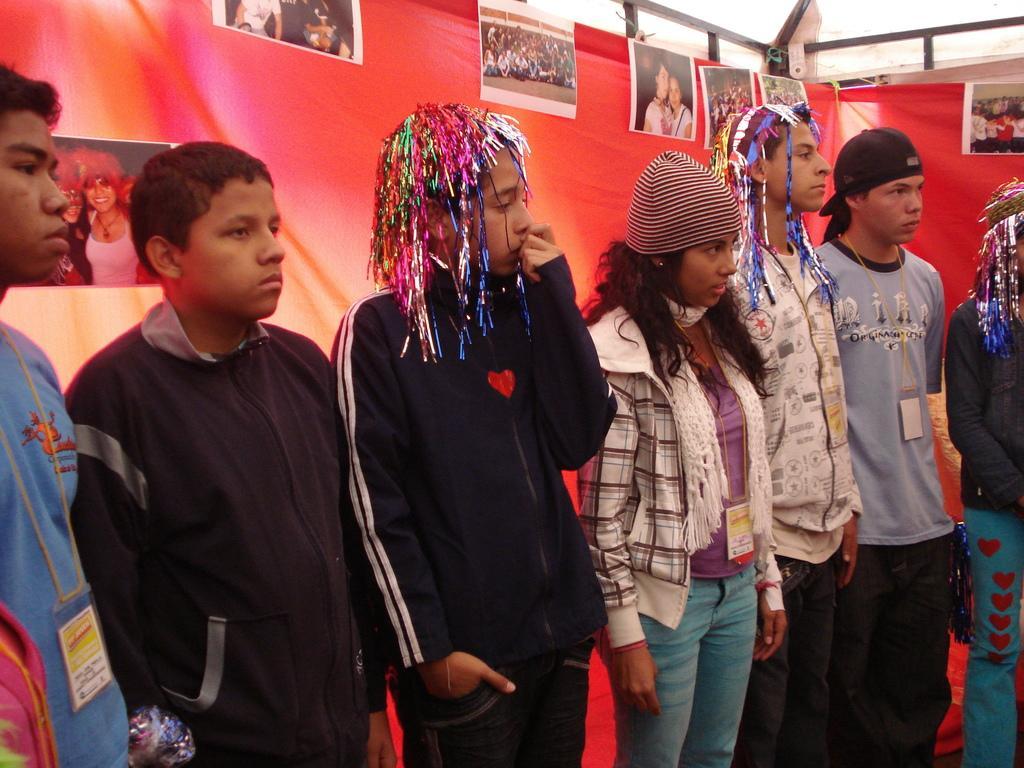What is happening in the image? There are people standing in the image. Can you describe the attire of some of the people? Some of the people are wearing caps. Are there any other identifiable features on the people? Some of the people are wearing tags. What can be seen in the background of the image? There is a cloth with photos pasted on it in the background of the image. What type of soda is being served at the family gathering in the image? There is no mention of soda or a family gathering in the image; it simply shows people standing with some wearing caps and tags. How many trees can be seen in the image? There are no trees visible in the image. 